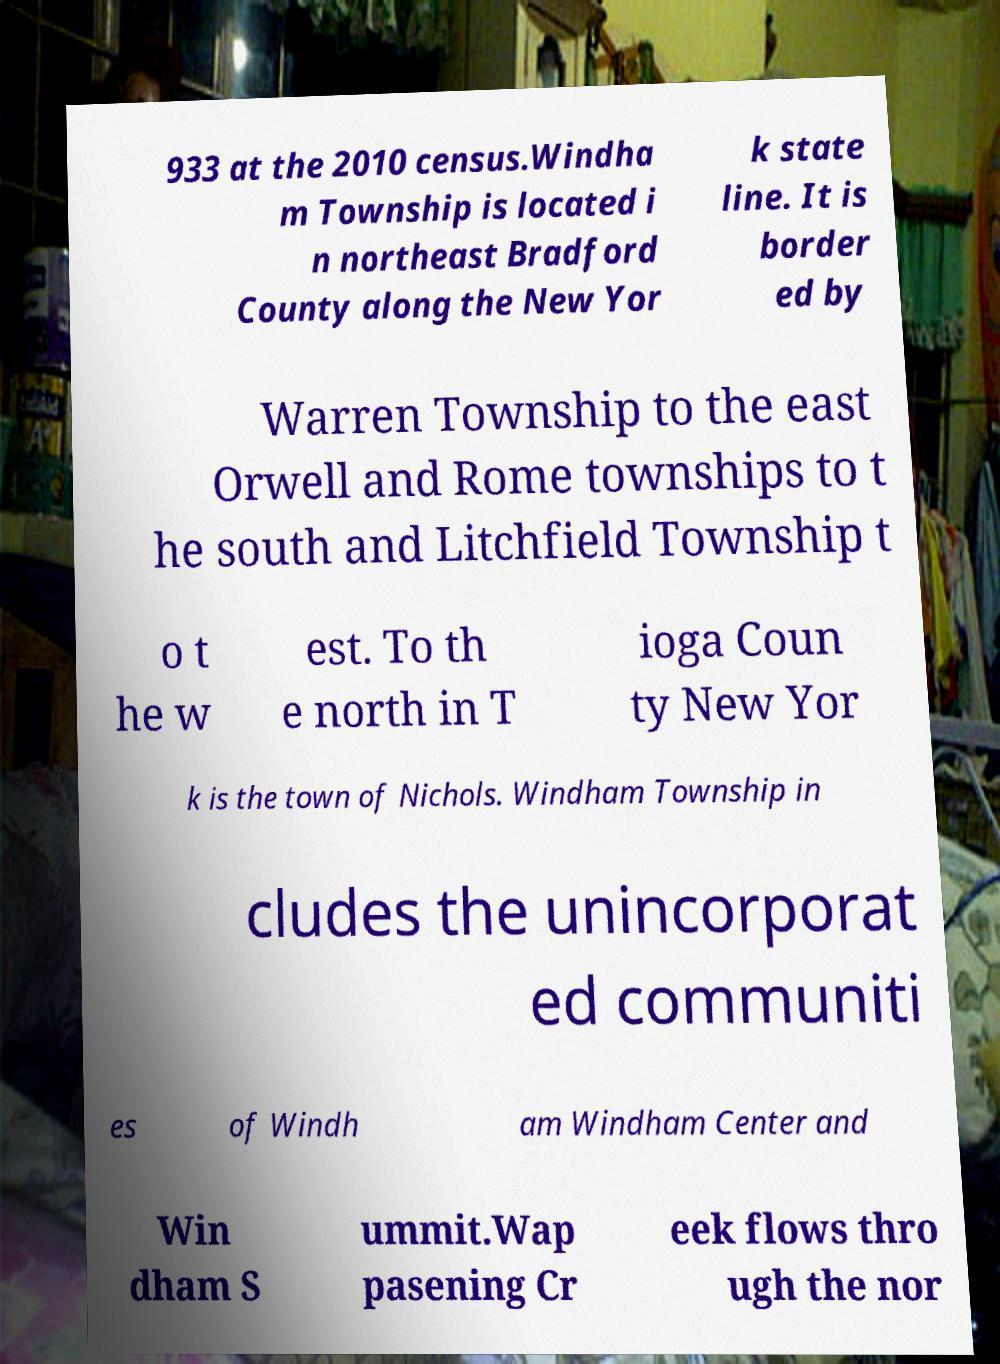Could you assist in decoding the text presented in this image and type it out clearly? 933 at the 2010 census.Windha m Township is located i n northeast Bradford County along the New Yor k state line. It is border ed by Warren Township to the east Orwell and Rome townships to t he south and Litchfield Township t o t he w est. To th e north in T ioga Coun ty New Yor k is the town of Nichols. Windham Township in cludes the unincorporat ed communiti es of Windh am Windham Center and Win dham S ummit.Wap pasening Cr eek flows thro ugh the nor 